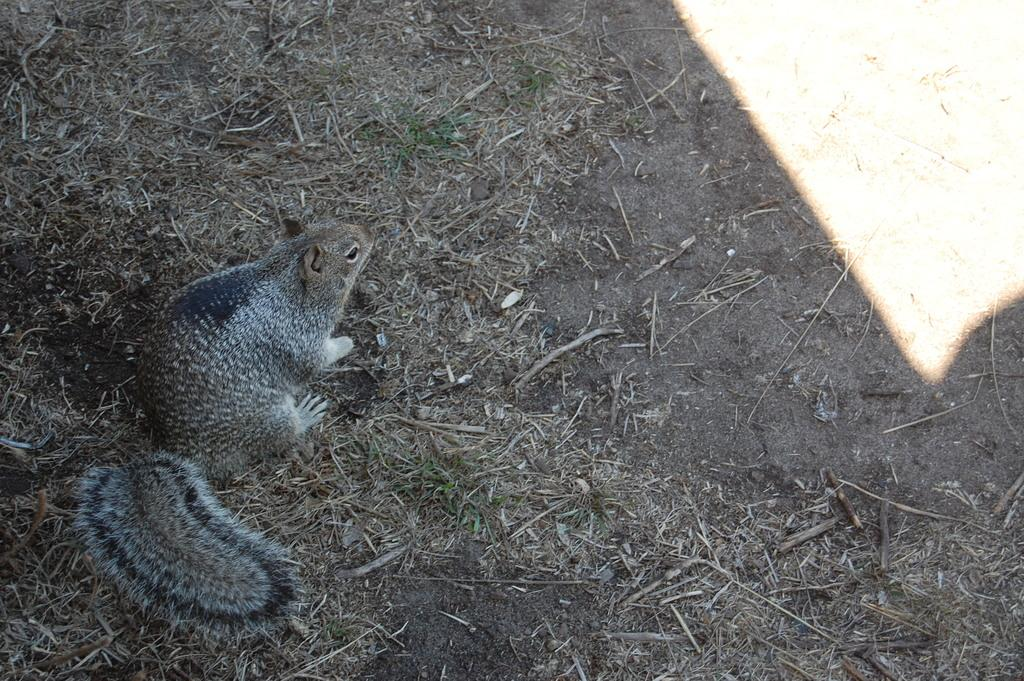What animal is present in the image? There is a squirrel in the image. What is the squirrel standing on? The squirrel is on a dried grass surface. What type of fruit is the squirrel holding in the image? There is no fruit present in the image; the squirrel is standing on a dried grass surface. 